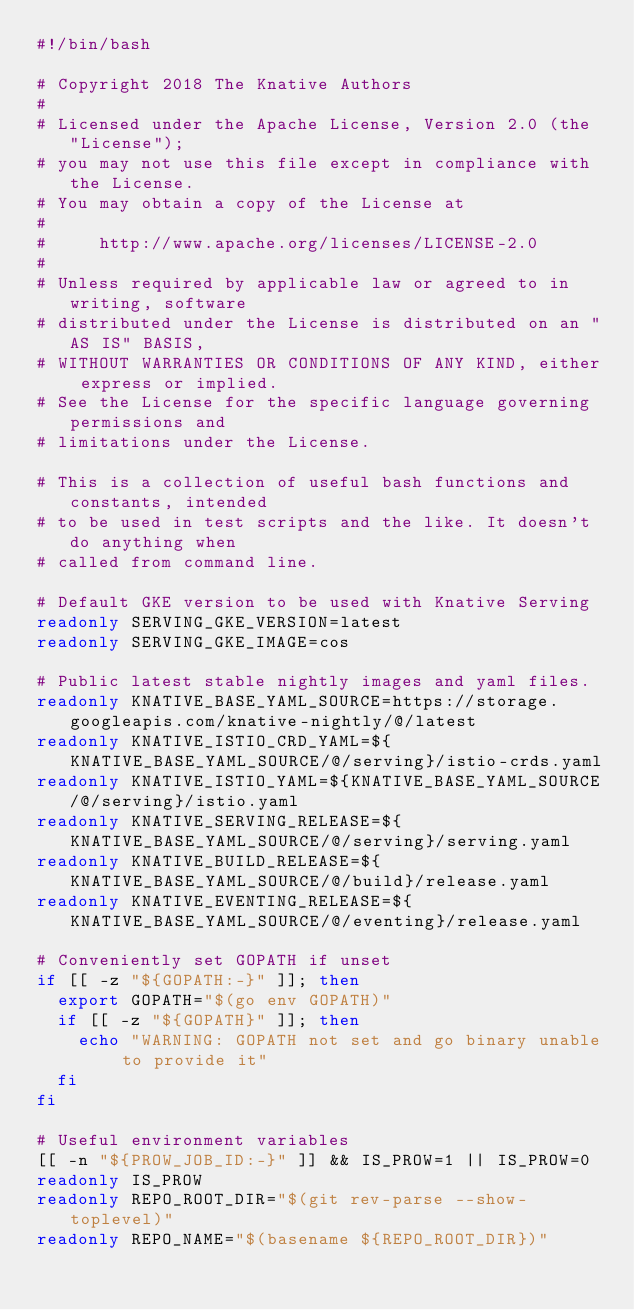Convert code to text. <code><loc_0><loc_0><loc_500><loc_500><_Bash_>#!/bin/bash

# Copyright 2018 The Knative Authors
#
# Licensed under the Apache License, Version 2.0 (the "License");
# you may not use this file except in compliance with the License.
# You may obtain a copy of the License at
#
#     http://www.apache.org/licenses/LICENSE-2.0
#
# Unless required by applicable law or agreed to in writing, software
# distributed under the License is distributed on an "AS IS" BASIS,
# WITHOUT WARRANTIES OR CONDITIONS OF ANY KIND, either express or implied.
# See the License for the specific language governing permissions and
# limitations under the License.

# This is a collection of useful bash functions and constants, intended
# to be used in test scripts and the like. It doesn't do anything when
# called from command line.

# Default GKE version to be used with Knative Serving
readonly SERVING_GKE_VERSION=latest
readonly SERVING_GKE_IMAGE=cos

# Public latest stable nightly images and yaml files.
readonly KNATIVE_BASE_YAML_SOURCE=https://storage.googleapis.com/knative-nightly/@/latest
readonly KNATIVE_ISTIO_CRD_YAML=${KNATIVE_BASE_YAML_SOURCE/@/serving}/istio-crds.yaml
readonly KNATIVE_ISTIO_YAML=${KNATIVE_BASE_YAML_SOURCE/@/serving}/istio.yaml
readonly KNATIVE_SERVING_RELEASE=${KNATIVE_BASE_YAML_SOURCE/@/serving}/serving.yaml
readonly KNATIVE_BUILD_RELEASE=${KNATIVE_BASE_YAML_SOURCE/@/build}/release.yaml
readonly KNATIVE_EVENTING_RELEASE=${KNATIVE_BASE_YAML_SOURCE/@/eventing}/release.yaml

# Conveniently set GOPATH if unset
if [[ -z "${GOPATH:-}" ]]; then
  export GOPATH="$(go env GOPATH)"
  if [[ -z "${GOPATH}" ]]; then
    echo "WARNING: GOPATH not set and go binary unable to provide it"
  fi
fi

# Useful environment variables
[[ -n "${PROW_JOB_ID:-}" ]] && IS_PROW=1 || IS_PROW=0
readonly IS_PROW
readonly REPO_ROOT_DIR="$(git rev-parse --show-toplevel)"
readonly REPO_NAME="$(basename ${REPO_ROOT_DIR})"
</code> 